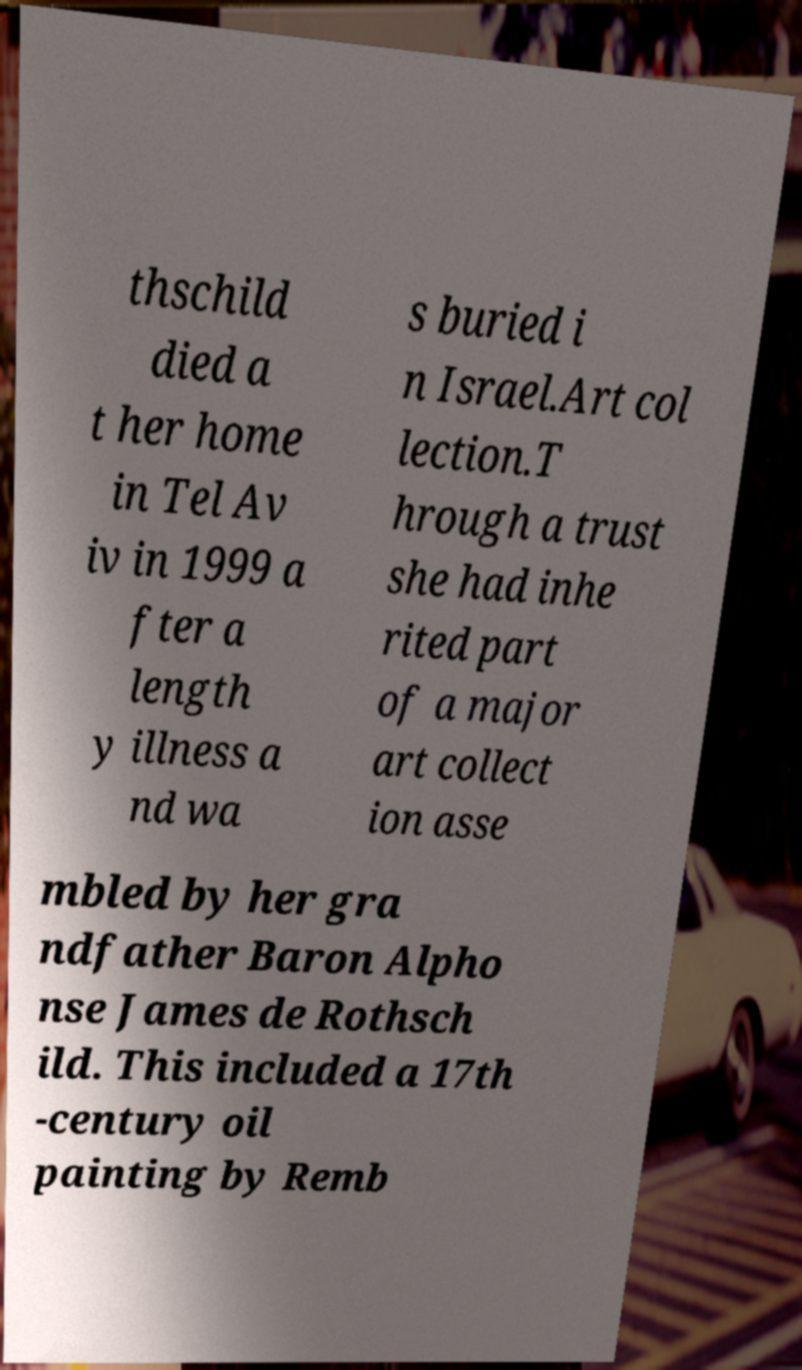Can you accurately transcribe the text from the provided image for me? thschild died a t her home in Tel Av iv in 1999 a fter a length y illness a nd wa s buried i n Israel.Art col lection.T hrough a trust she had inhe rited part of a major art collect ion asse mbled by her gra ndfather Baron Alpho nse James de Rothsch ild. This included a 17th -century oil painting by Remb 